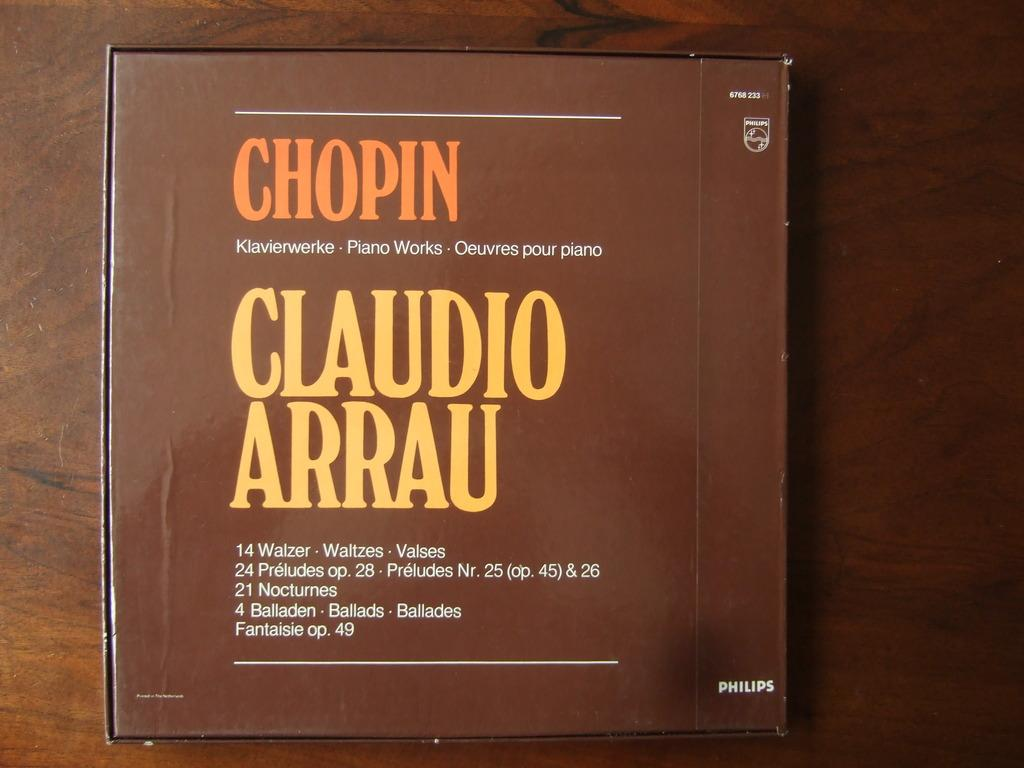<image>
Relay a brief, clear account of the picture shown. A Chopin CD contains 4 ballads, 14 waltzes and 21 Nocturnes. 